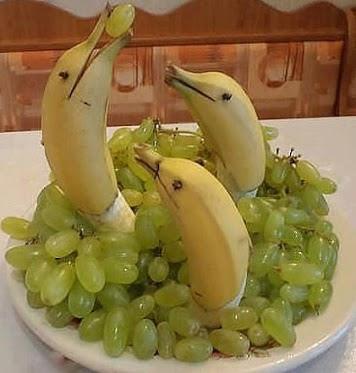How many banana dolphins are there?
Give a very brief answer. 3. How many bananas are visible?
Give a very brief answer. 2. How many people are wearing blue shorts?
Give a very brief answer. 0. 